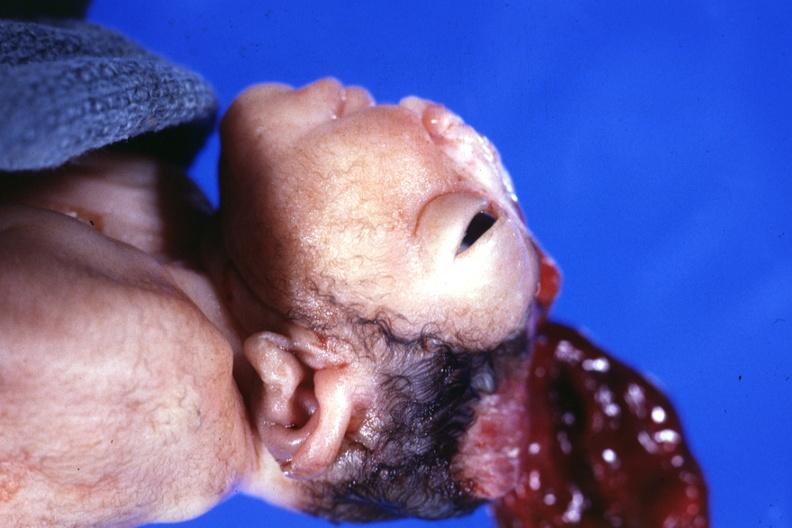s anencephaly present?
Answer the question using a single word or phrase. Yes 